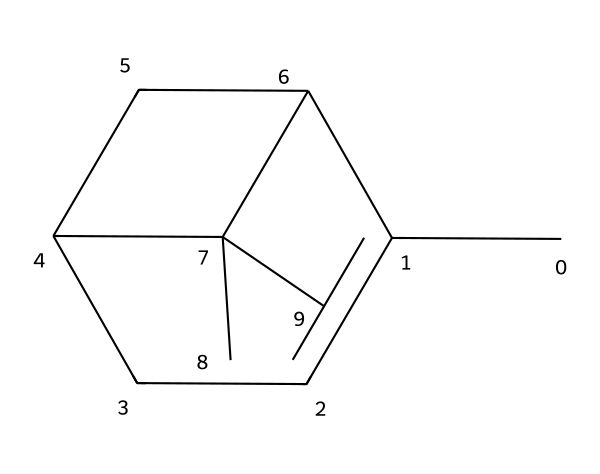What is the name of this chemical? The SMILES representation corresponds to a compound known as pinene, a well-known terpene often associated with pine-scented products.
Answer: pinene How many carbon atoms are in pinene? Analyzing the SMILES notation, we count a total of 10 carbon atoms represented in the structure.
Answer: 10 What is the predominant functional group in pinene? Pinene primarily features a double bond in its structure, indicating the presence of an alkene functional group.
Answer: alkene How many rings are present in the structure of pinene? The structure indicates that there are two distinct carbon rings present, based on the interconnected carbon atoms forming cyclic structures.
Answer: 2 Is pinene a saturated or unsaturated compound? The presence of a double bond in its structure categorizes pinene as an unsaturated compound, meaning it does not have maximum hydrogen saturation.
Answer: unsaturated What type of compound is pinene classified as? Pinene is classified as a terpene, which is a type of organic compound frequently found in essential oils and known for its aromatic properties.
Answer: terpene What is the molecular formula of pinene? Counting the number of each type of atom from the structure, we derive the molecular formula C10H16 for pinene.
Answer: C10H16 